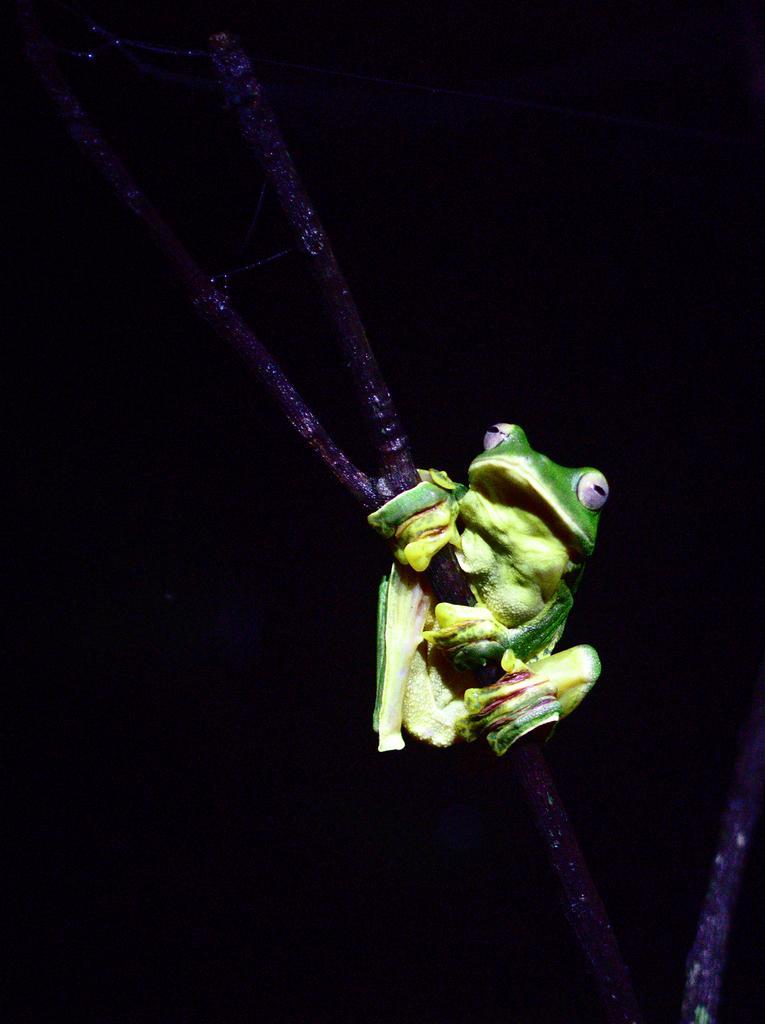Could you give a brief overview of what you see in this image? In the foreground of this image, there is a toy frog holding a stem and there is a dark background. 